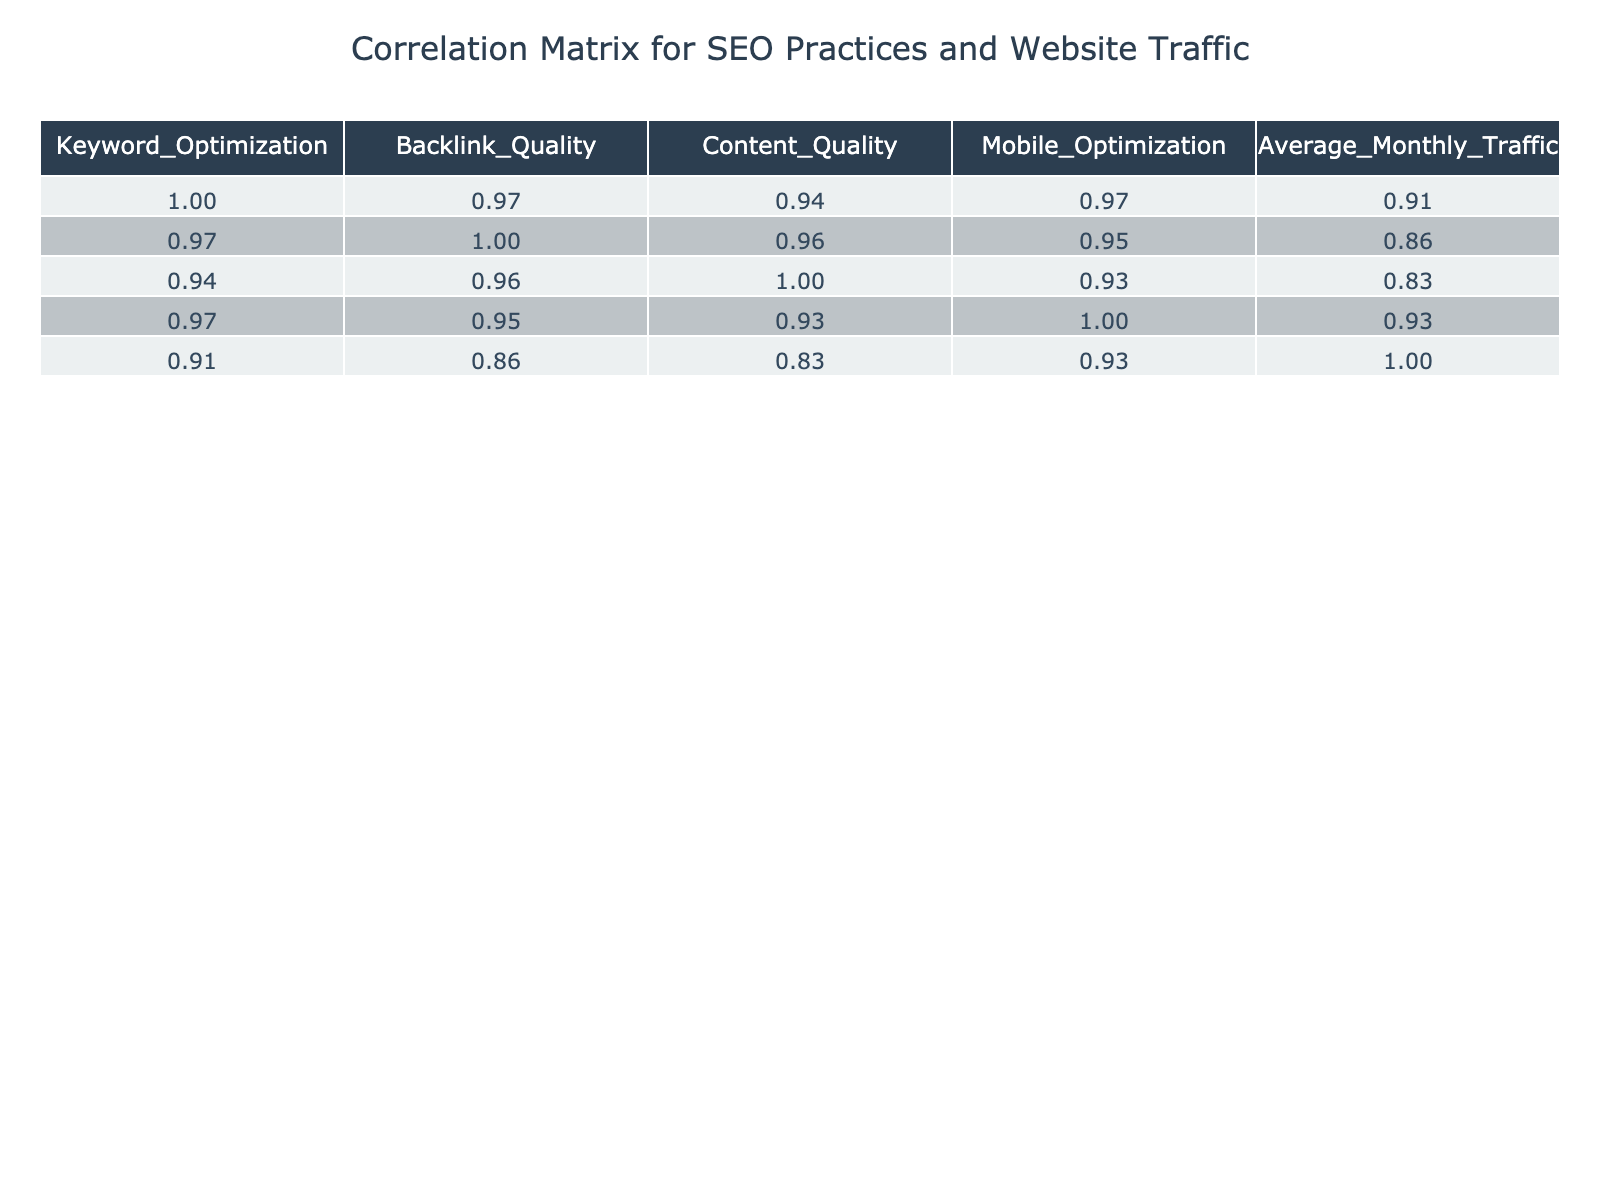What is the correlation between Backlink Quality and Average Monthly Traffic? According to the correlation matrix, the value in the Backlink Quality column and the Average Monthly Traffic row is approximately 0.91. This indicates a very strong positive correlation, meaning as the quality of backlinks increases, so does the average monthly traffic.
Answer: 0.91 What is the Average Monthly Traffic for businesses that have High Mobile Optimization? In the table, the Average Monthly Traffic for entries with High Mobile Optimization are: 1500, 2000, 2500, and 2300. Adding these values gives 10800, and dividing by the count of entries (4) results in 2700.
Answer: 2700 Is there a correlation between SEO Practice and Mobile Optimization? The correlation matrix indicates a value of approximately 0.92 between SEO Practice and Mobile Optimization. This strong positive correlation suggests that as the SEO Practice level increases, the Mobile Optimization also tends to increase.
Answer: Yes What is the Average Monthly Traffic for Medium SEO Practice? The Average Monthly Traffic for Medium SEO Practice shows values of 900, 800, and 700. Summing these gives 2400, and dividing by the number of entries (3) results in an average of 800.
Answer: 800 Which SEO practice level has the highest Average Monthly Traffic? By reviewing the Average Monthly Traffic values for each SEO Practice level, High SEO Practice has the maximum Average Monthly Traffic of 2500.
Answer: High What is the difference in Average Monthly Traffic between Low and High SEO Practices? The Average Monthly Traffic for Low SEO Practice totals to 300, while for High SEO Practice it is 2500. The difference is calculated as 2500 - 300 = 2200.
Answer: 2200 Is it true that High Keyword Optimization corresponds to the highest Average Monthly Traffic? Analyzing the data shows that while High Keyword Optimization entries exist, the one with the highest traffic (2500) corresponds to a High SEO practice, which confirms the statement as true.
Answer: Yes What is the Average score for Content Quality across all practices? The Average scores for Content Quality in the table are 85, 80, 55, 90, 75, 80, 91, 50. Summing these scores gives 706, and dividing by the number of entries (8) results in an average of 88.25.
Answer: 88.25 